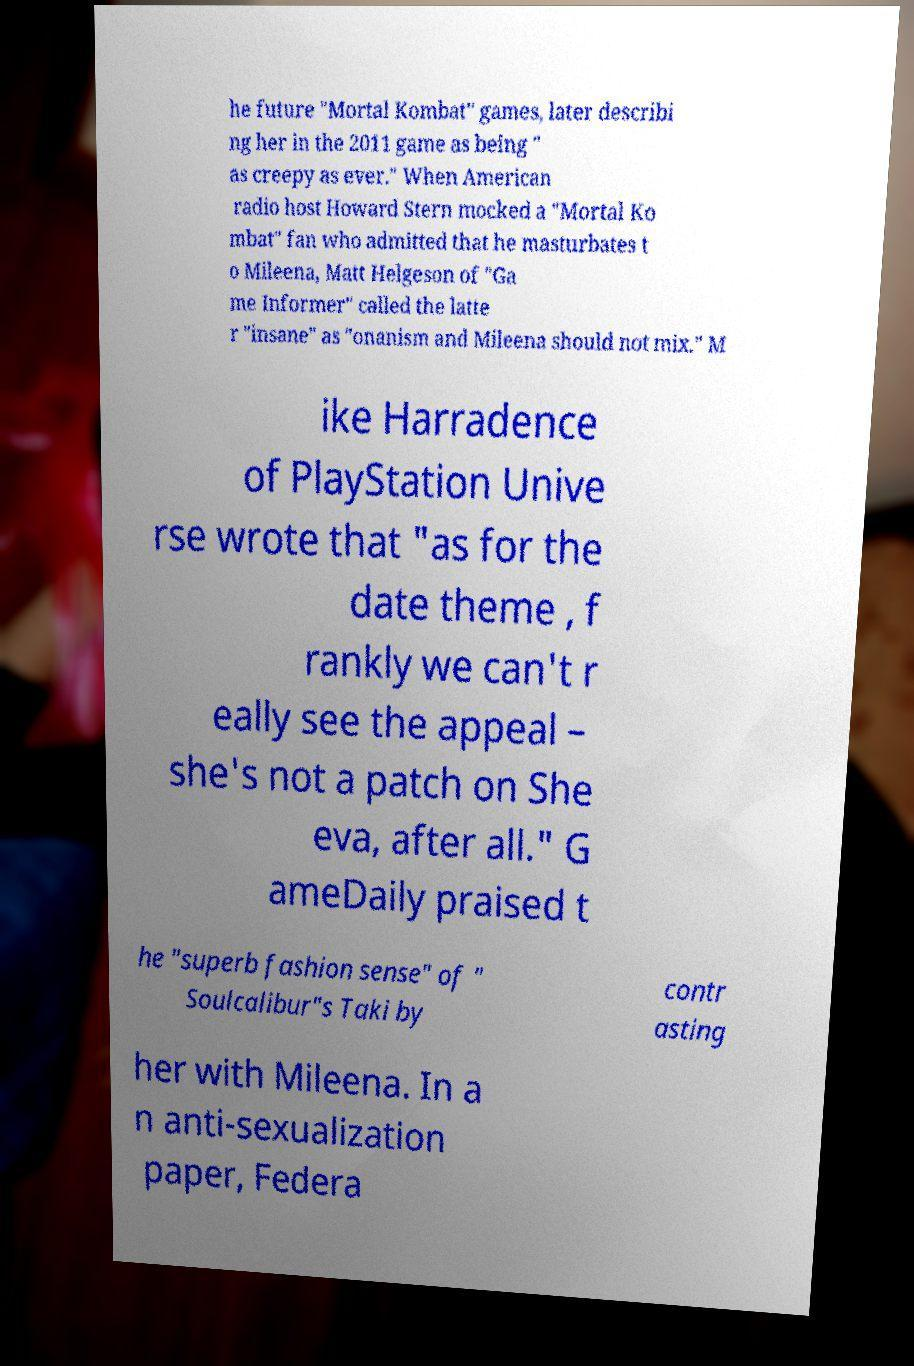For documentation purposes, I need the text within this image transcribed. Could you provide that? he future "Mortal Kombat" games, later describi ng her in the 2011 game as being " as creepy as ever." When American radio host Howard Stern mocked a "Mortal Ko mbat" fan who admitted that he masturbates t o Mileena, Matt Helgeson of "Ga me Informer" called the latte r "insane" as "onanism and Mileena should not mix." M ike Harradence of PlayStation Unive rse wrote that "as for the date theme , f rankly we can't r eally see the appeal – she's not a patch on She eva, after all." G ameDaily praised t he "superb fashion sense" of " Soulcalibur"s Taki by contr asting her with Mileena. In a n anti-sexualization paper, Federa 